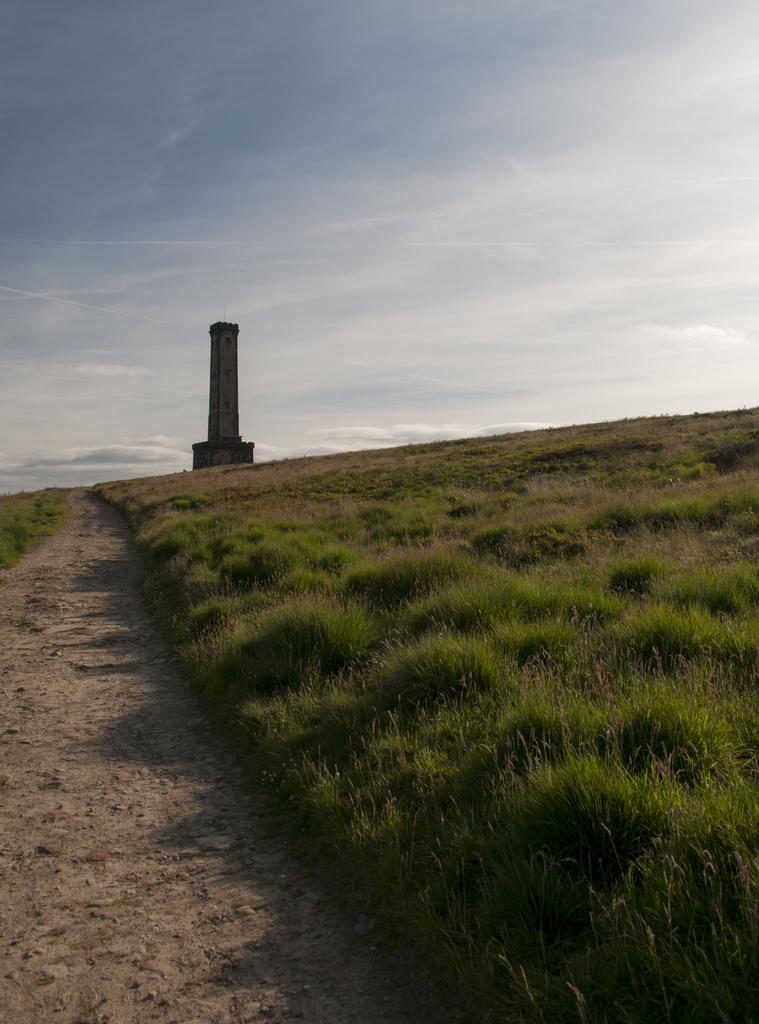What type of terrain is visible in the image? There is grass and sand visible in the image. What separates the grass and sand in the image? There is a walkway at the bottom of the image. What can be seen in the background of the image? There is a tower in the background of the image. What is visible at the top of the image? The sky is visible at the top of the image. Can you see a plough working in the grassy area of the image? There is no plough present in the image. Is there any steam coming from the tower in the background? There is no steam visible in the image. 